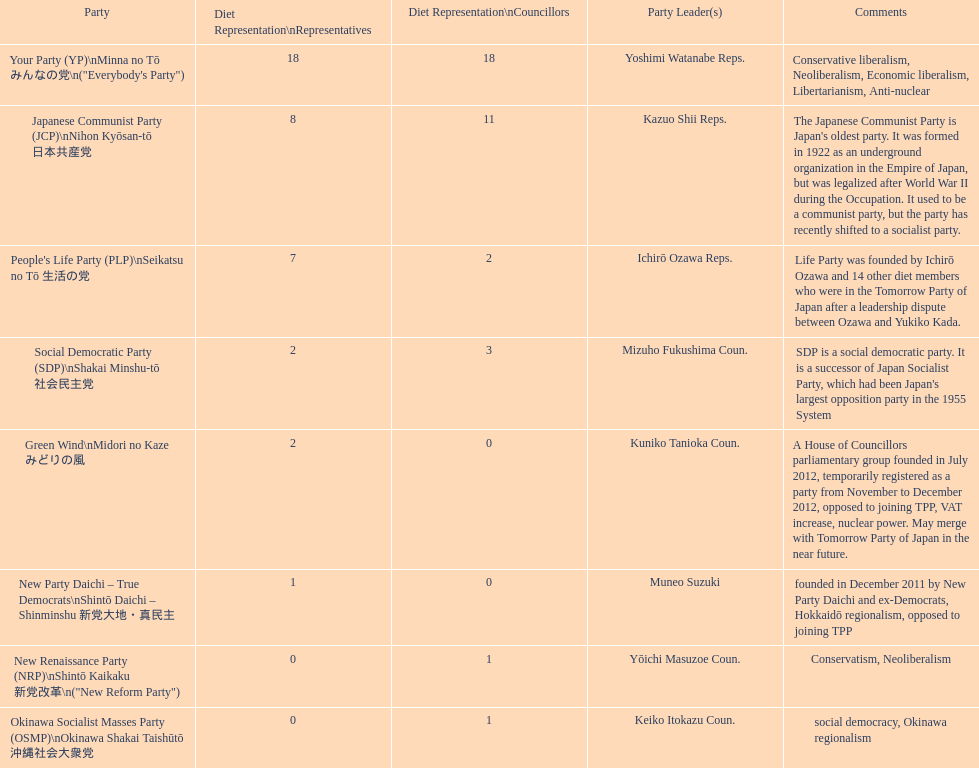Among the parties in the diet, which one has the greatest number of representatives? Your Party. 